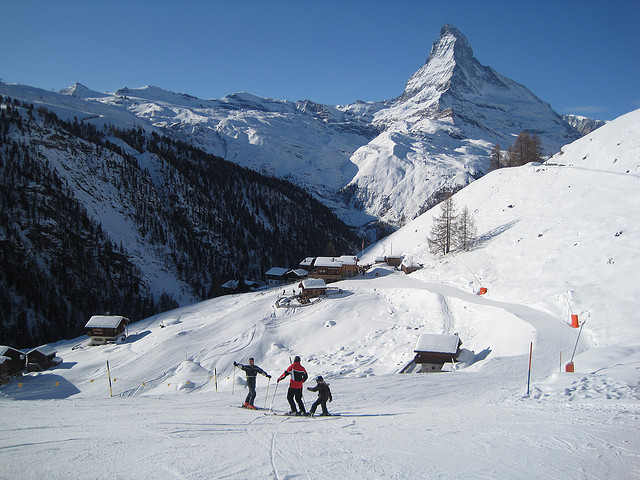Where is this mountain located? The mountain in the image is the Matterhorn, and it's located on the border between Switzerland and Italy. It's one of the highest peaks in the Alps and a popular destination for climbers and skiers. What are the best times of year to visit this area for skiing? The best time to visit the Matterhorn for skiing is typically during the winter months, from late November to early April. This is when the snow conditions are most reliable, and the ski resorts are fully operational. 